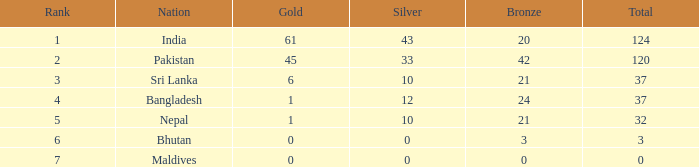Would you mind parsing the complete table? {'header': ['Rank', 'Nation', 'Gold', 'Silver', 'Bronze', 'Total'], 'rows': [['1', 'India', '61', '43', '20', '124'], ['2', 'Pakistan', '45', '33', '42', '120'], ['3', 'Sri Lanka', '6', '10', '21', '37'], ['4', 'Bangladesh', '1', '12', '24', '37'], ['5', 'Nepal', '1', '10', '21', '32'], ['6', 'Bhutan', '0', '0', '3', '3'], ['7', 'Maldives', '0', '0', '0', '0']]} How much Silver has a Rank of 7? 1.0. 